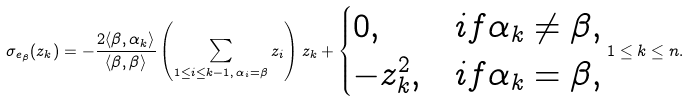Convert formula to latex. <formula><loc_0><loc_0><loc_500><loc_500>\sigma _ { e _ { \beta } } ( z _ { k } ) = - \frac { 2 \langle \beta , \alpha _ { k } \rangle } { \langle \beta , \beta \rangle } \left ( \sum _ { 1 \leq i \leq k - 1 , \, \alpha _ { i } = \beta } z _ { i } \right ) z _ { k } + \begin{cases} 0 , & i f \alpha _ { k } \neq \beta , \\ - z _ { k } ^ { 2 } , & i f \alpha _ { k } = \beta , \end{cases} 1 \leq k \leq n .</formula> 